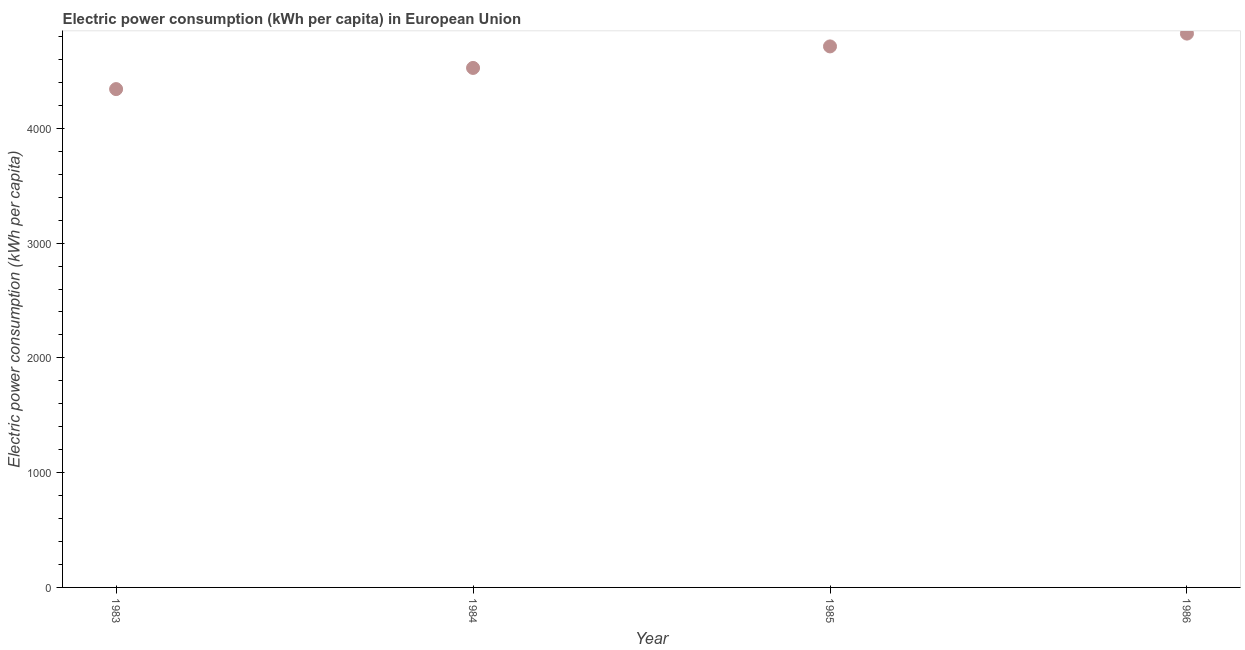What is the electric power consumption in 1986?
Make the answer very short. 4825.18. Across all years, what is the maximum electric power consumption?
Give a very brief answer. 4825.18. Across all years, what is the minimum electric power consumption?
Your answer should be compact. 4341.66. What is the sum of the electric power consumption?
Give a very brief answer. 1.84e+04. What is the difference between the electric power consumption in 1984 and 1986?
Your response must be concise. -299.15. What is the average electric power consumption per year?
Provide a short and direct response. 4601.61. What is the median electric power consumption?
Give a very brief answer. 4619.81. In how many years, is the electric power consumption greater than 2400 kWh per capita?
Provide a short and direct response. 4. Do a majority of the years between 1983 and 1986 (inclusive) have electric power consumption greater than 4600 kWh per capita?
Offer a very short reply. No. What is the ratio of the electric power consumption in 1983 to that in 1986?
Offer a terse response. 0.9. What is the difference between the highest and the second highest electric power consumption?
Keep it short and to the point. 111.58. Is the sum of the electric power consumption in 1983 and 1986 greater than the maximum electric power consumption across all years?
Offer a very short reply. Yes. What is the difference between the highest and the lowest electric power consumption?
Keep it short and to the point. 483.52. Does the electric power consumption monotonically increase over the years?
Ensure brevity in your answer.  Yes. How many dotlines are there?
Make the answer very short. 1. What is the difference between two consecutive major ticks on the Y-axis?
Provide a short and direct response. 1000. Are the values on the major ticks of Y-axis written in scientific E-notation?
Your response must be concise. No. What is the title of the graph?
Keep it short and to the point. Electric power consumption (kWh per capita) in European Union. What is the label or title of the Y-axis?
Offer a very short reply. Electric power consumption (kWh per capita). What is the Electric power consumption (kWh per capita) in 1983?
Offer a terse response. 4341.66. What is the Electric power consumption (kWh per capita) in 1984?
Offer a very short reply. 4526.02. What is the Electric power consumption (kWh per capita) in 1985?
Ensure brevity in your answer.  4713.59. What is the Electric power consumption (kWh per capita) in 1986?
Offer a very short reply. 4825.18. What is the difference between the Electric power consumption (kWh per capita) in 1983 and 1984?
Your response must be concise. -184.37. What is the difference between the Electric power consumption (kWh per capita) in 1983 and 1985?
Give a very brief answer. -371.93. What is the difference between the Electric power consumption (kWh per capita) in 1983 and 1986?
Your answer should be very brief. -483.52. What is the difference between the Electric power consumption (kWh per capita) in 1984 and 1985?
Offer a terse response. -187.57. What is the difference between the Electric power consumption (kWh per capita) in 1984 and 1986?
Provide a succinct answer. -299.15. What is the difference between the Electric power consumption (kWh per capita) in 1985 and 1986?
Ensure brevity in your answer.  -111.58. What is the ratio of the Electric power consumption (kWh per capita) in 1983 to that in 1985?
Make the answer very short. 0.92. What is the ratio of the Electric power consumption (kWh per capita) in 1984 to that in 1985?
Give a very brief answer. 0.96. What is the ratio of the Electric power consumption (kWh per capita) in 1984 to that in 1986?
Make the answer very short. 0.94. 